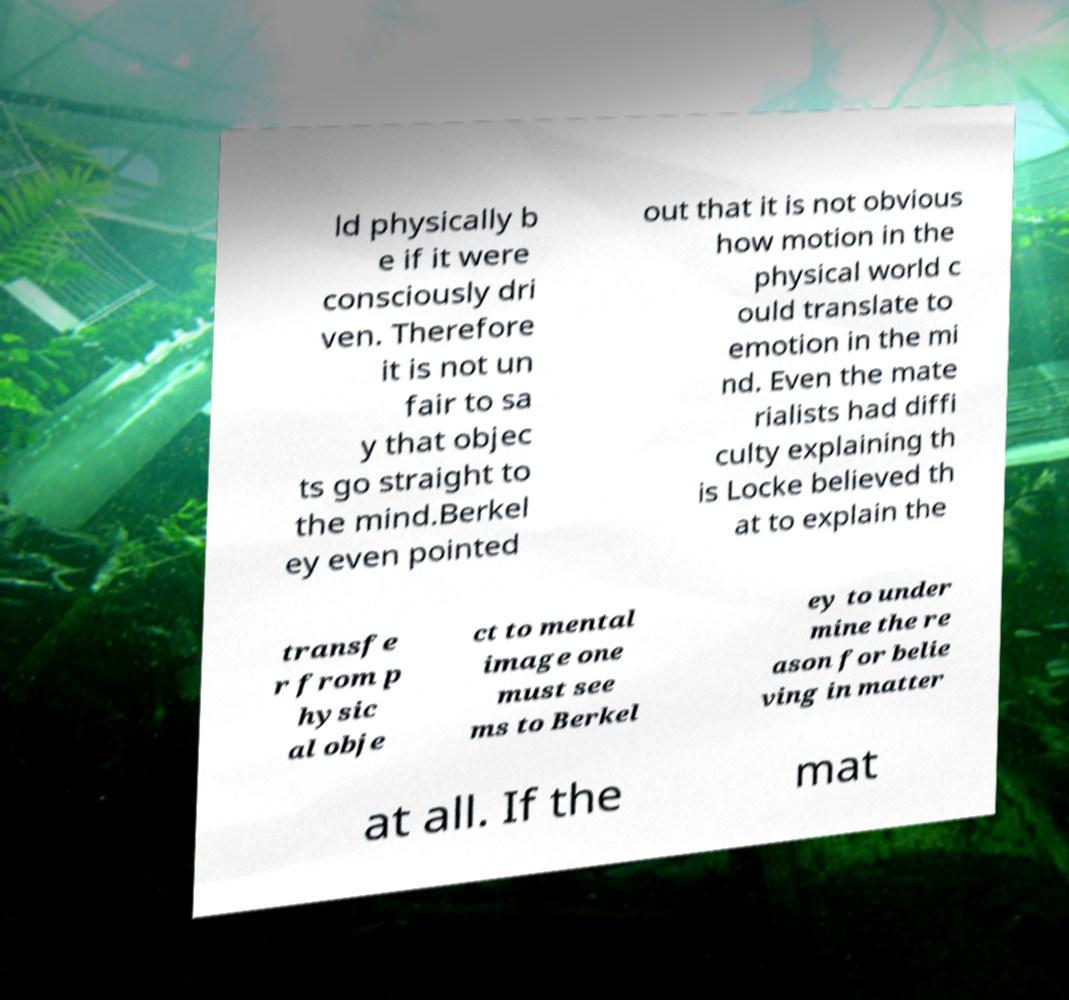Could you assist in decoding the text presented in this image and type it out clearly? ld physically b e if it were consciously dri ven. Therefore it is not un fair to sa y that objec ts go straight to the mind.Berkel ey even pointed out that it is not obvious how motion in the physical world c ould translate to emotion in the mi nd. Even the mate rialists had diffi culty explaining th is Locke believed th at to explain the transfe r from p hysic al obje ct to mental image one must see ms to Berkel ey to under mine the re ason for belie ving in matter at all. If the mat 